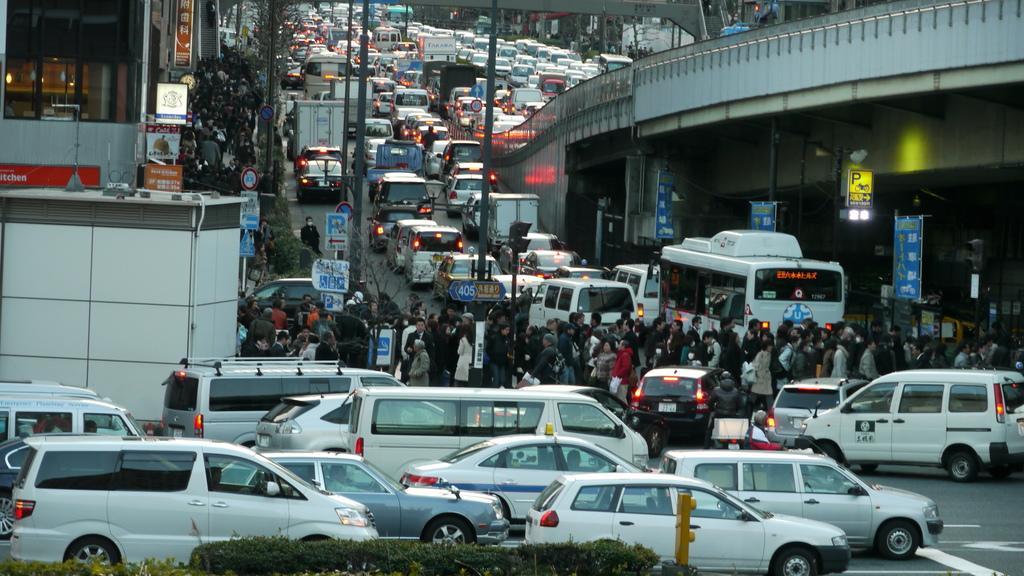Please provide a concise description of this image. Vehicles are on the road. In-between of these vehicles there are people. Here we can see buildings, bridge, Sign Boards, hoarding and poles. In-front of this building there are plants. 